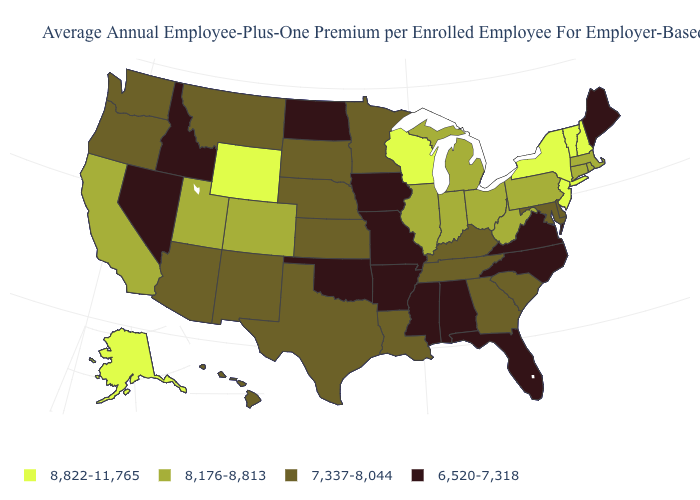Name the states that have a value in the range 6,520-7,318?
Write a very short answer. Alabama, Arkansas, Florida, Idaho, Iowa, Maine, Mississippi, Missouri, Nevada, North Carolina, North Dakota, Oklahoma, Virginia. Name the states that have a value in the range 7,337-8,044?
Quick response, please. Arizona, Delaware, Georgia, Hawaii, Kansas, Kentucky, Louisiana, Maryland, Minnesota, Montana, Nebraska, New Mexico, Oregon, South Carolina, South Dakota, Tennessee, Texas, Washington. Name the states that have a value in the range 7,337-8,044?
Keep it brief. Arizona, Delaware, Georgia, Hawaii, Kansas, Kentucky, Louisiana, Maryland, Minnesota, Montana, Nebraska, New Mexico, Oregon, South Carolina, South Dakota, Tennessee, Texas, Washington. Is the legend a continuous bar?
Be succinct. No. How many symbols are there in the legend?
Write a very short answer. 4. Name the states that have a value in the range 8,822-11,765?
Be succinct. Alaska, New Hampshire, New Jersey, New York, Vermont, Wisconsin, Wyoming. What is the value of Vermont?
Concise answer only. 8,822-11,765. What is the lowest value in states that border Wisconsin?
Answer briefly. 6,520-7,318. Name the states that have a value in the range 6,520-7,318?
Answer briefly. Alabama, Arkansas, Florida, Idaho, Iowa, Maine, Mississippi, Missouri, Nevada, North Carolina, North Dakota, Oklahoma, Virginia. What is the value of Arkansas?
Answer briefly. 6,520-7,318. What is the value of Illinois?
Keep it brief. 8,176-8,813. What is the highest value in the South ?
Give a very brief answer. 8,176-8,813. Among the states that border Washington , which have the highest value?
Quick response, please. Oregon. Which states have the lowest value in the MidWest?
Quick response, please. Iowa, Missouri, North Dakota. What is the lowest value in the USA?
Be succinct. 6,520-7,318. 